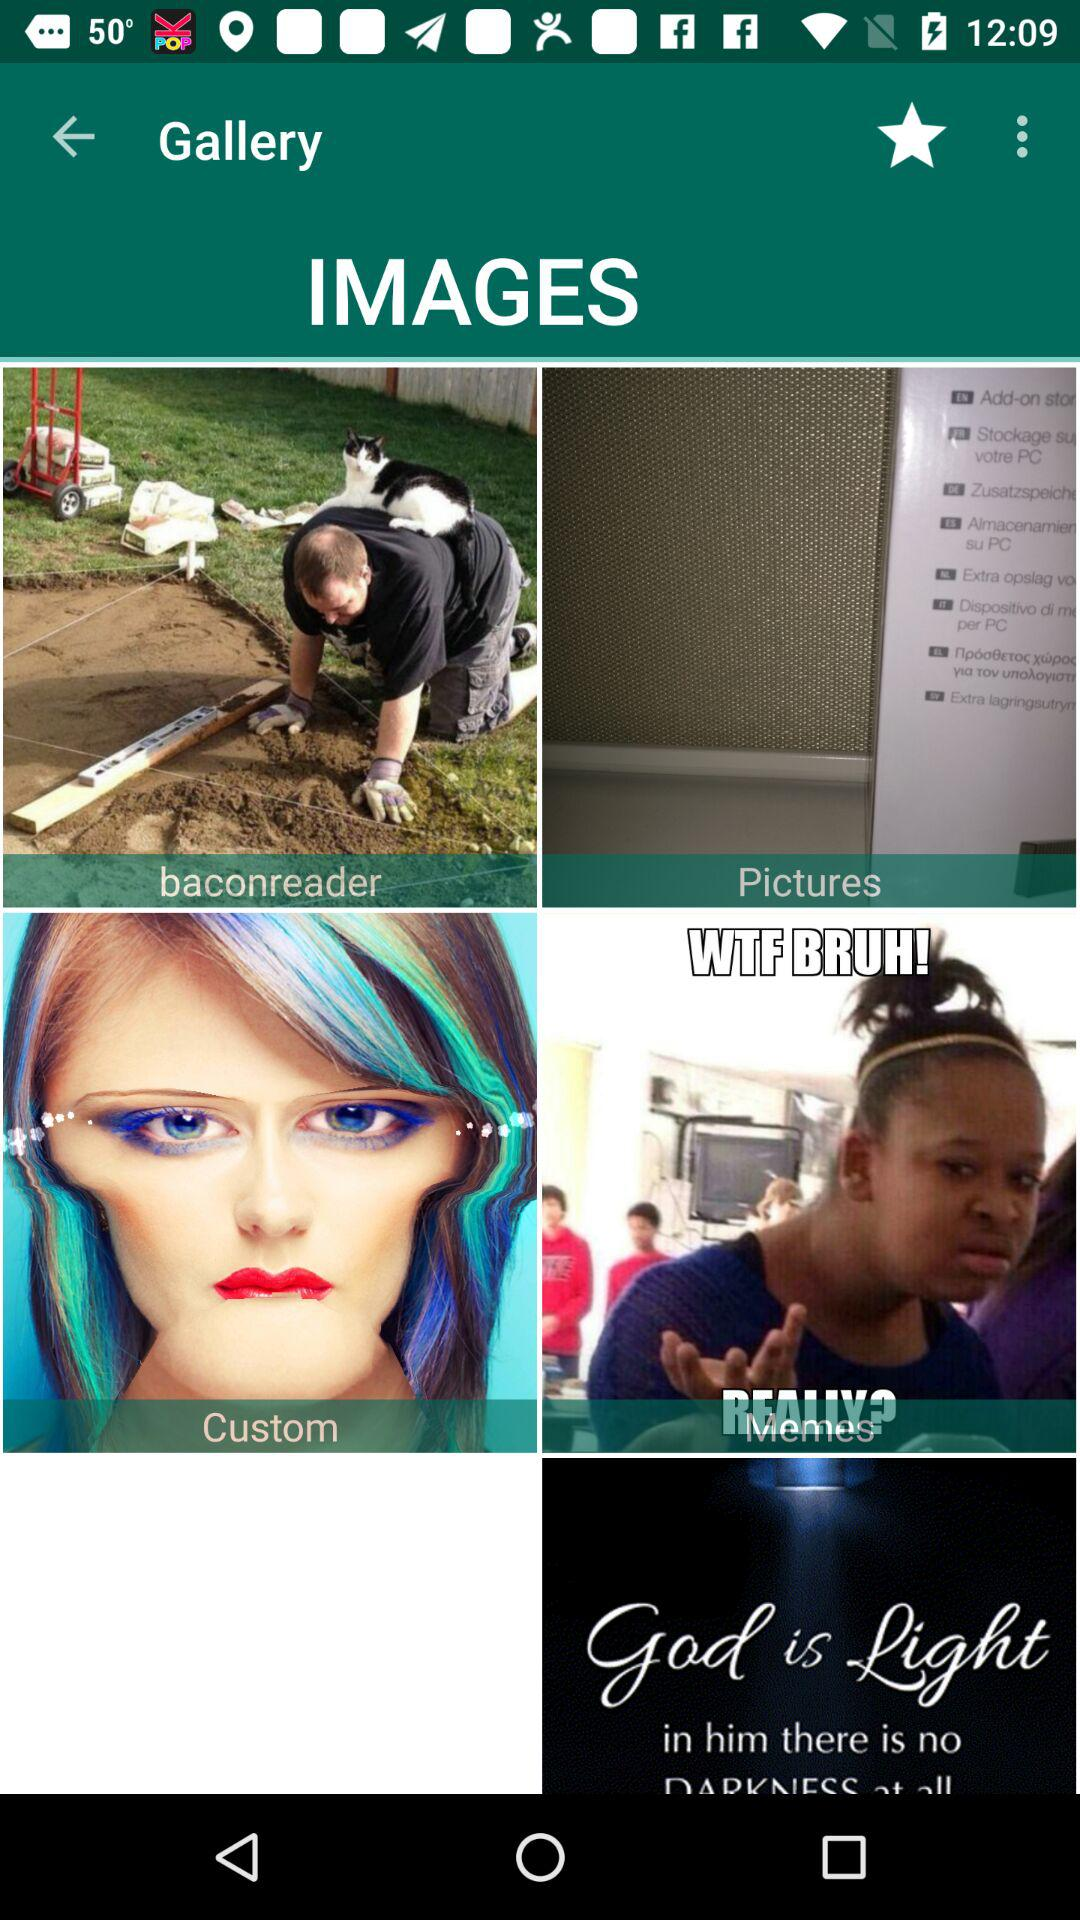What is the application name?
When the provided information is insufficient, respond with <no answer>. <no answer> 